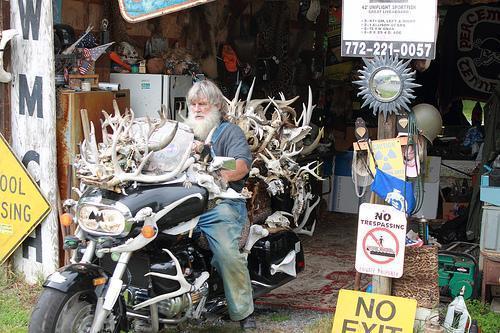How many orange lights can you see on the motorcycle?
Give a very brief answer. 3. 